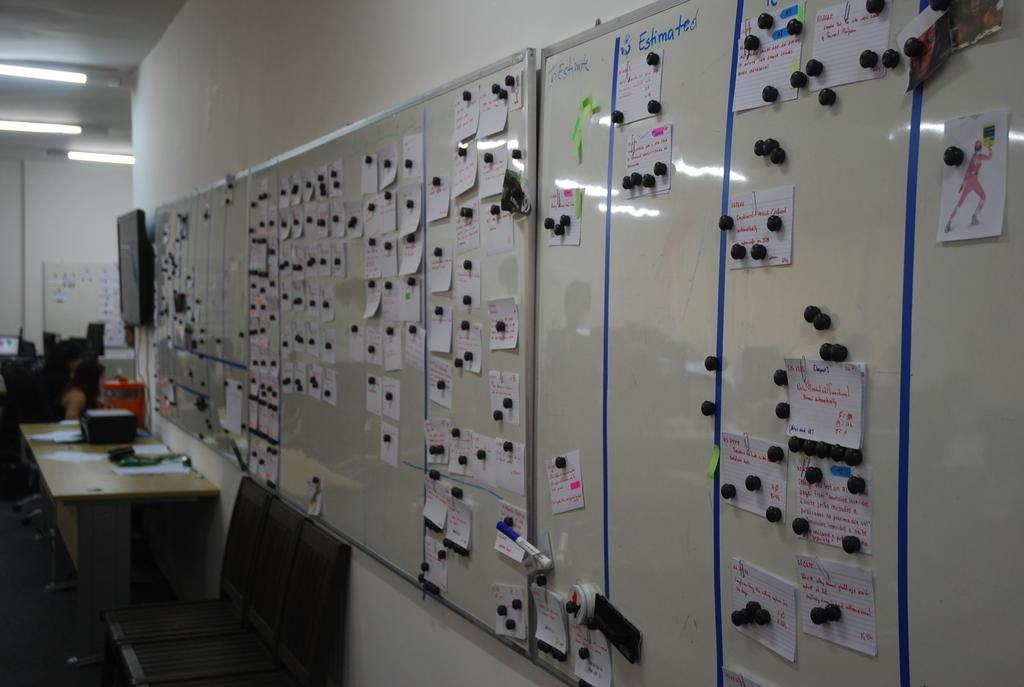How would you summarize this image in a sentence or two? There are sticky notes on the board, this is television, there is paper on the table, these are chairs, this is wall. 